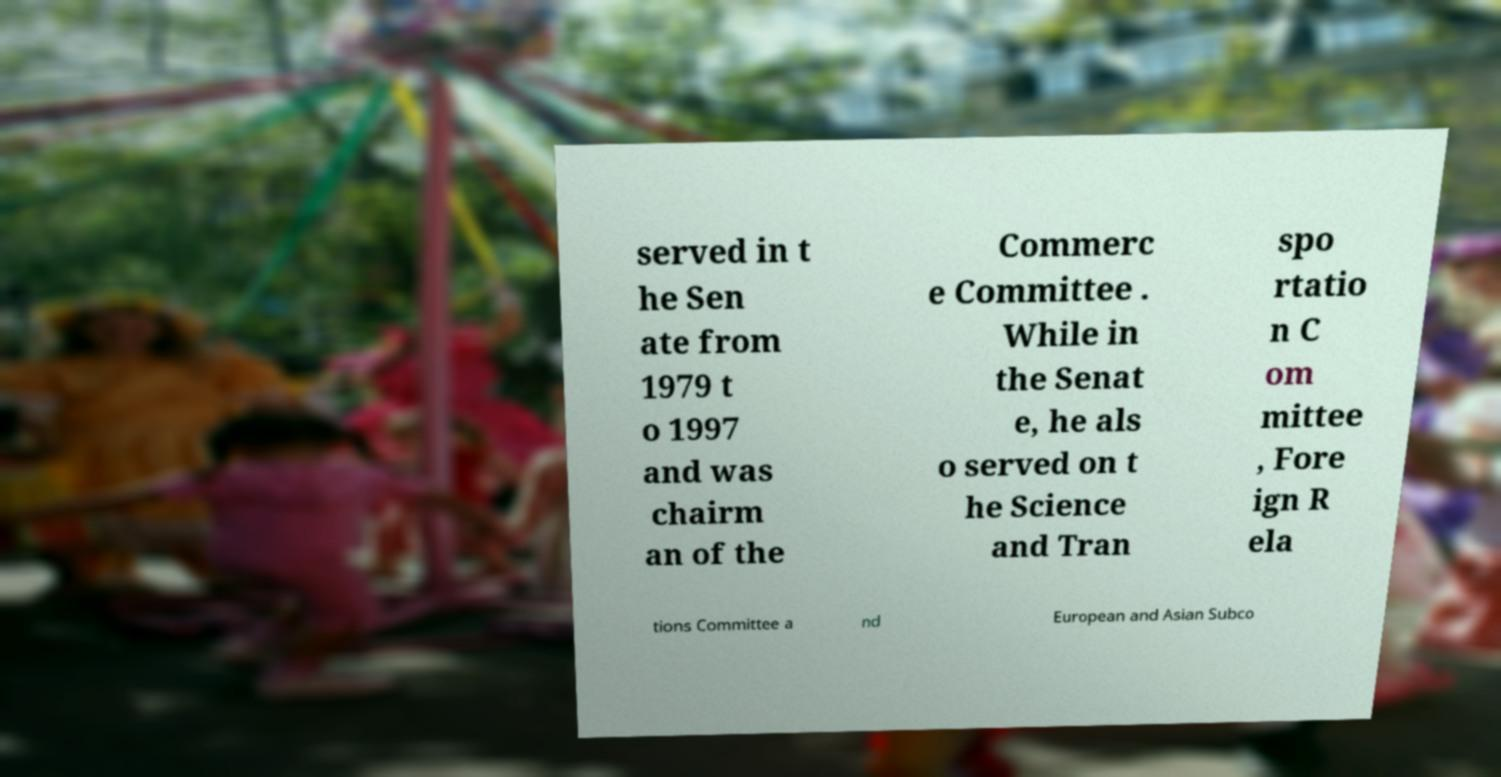Can you accurately transcribe the text from the provided image for me? served in t he Sen ate from 1979 t o 1997 and was chairm an of the Commerc e Committee . While in the Senat e, he als o served on t he Science and Tran spo rtatio n C om mittee , Fore ign R ela tions Committee a nd European and Asian Subco 